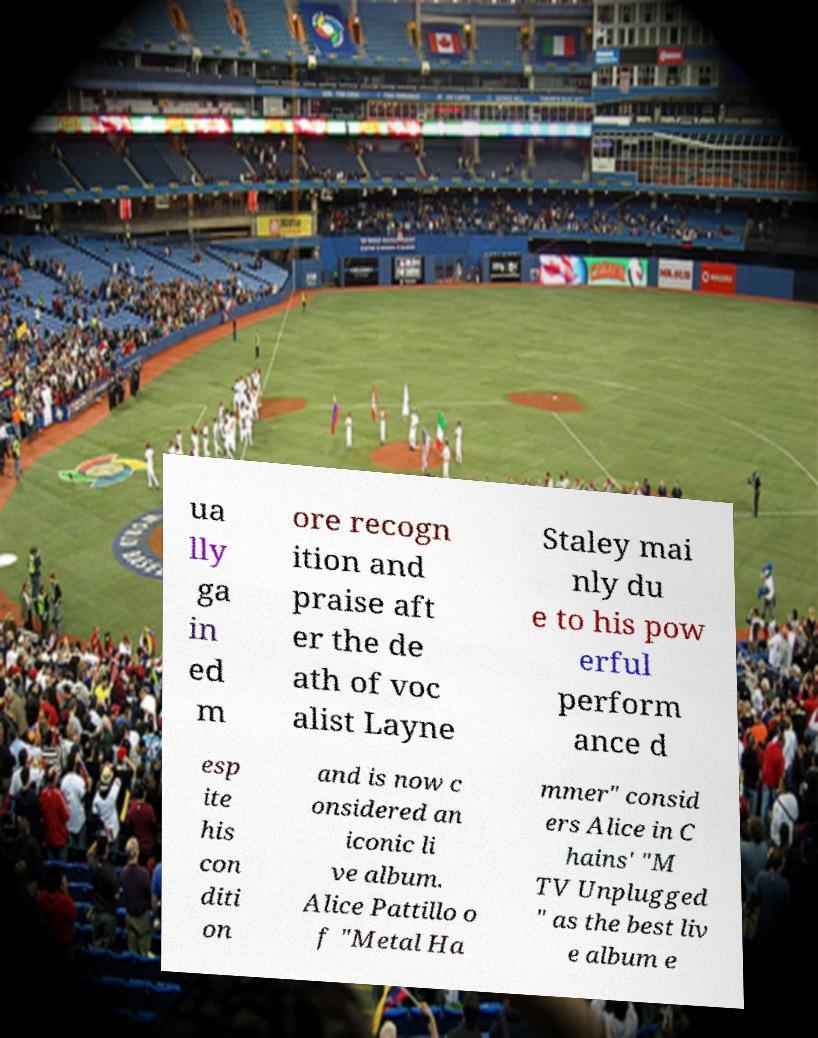Please identify and transcribe the text found in this image. ua lly ga in ed m ore recogn ition and praise aft er the de ath of voc alist Layne Staley mai nly du e to his pow erful perform ance d esp ite his con diti on and is now c onsidered an iconic li ve album. Alice Pattillo o f "Metal Ha mmer" consid ers Alice in C hains' "M TV Unplugged " as the best liv e album e 